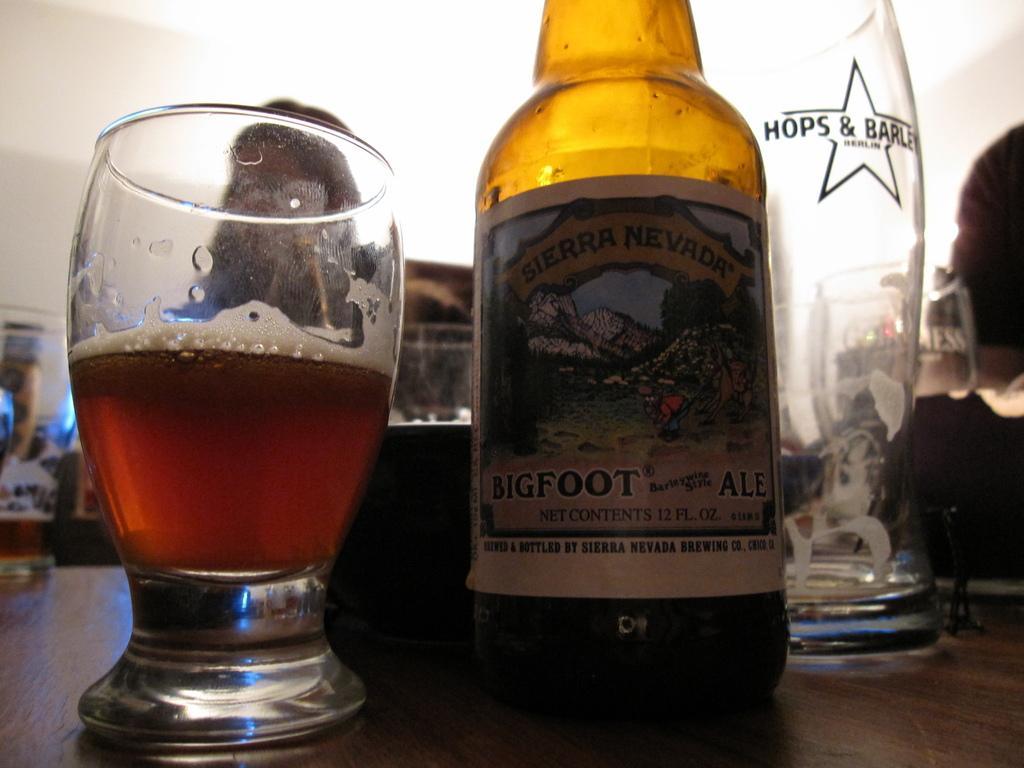Describe this image in one or two sentences. In this image, this looks like a beer bottle and glasses, which are placed on the wooden board. This glass contains alcohol. 